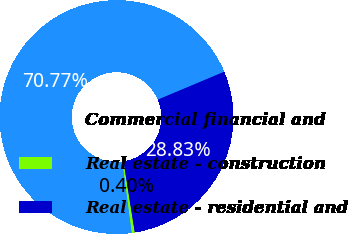Convert chart to OTSL. <chart><loc_0><loc_0><loc_500><loc_500><pie_chart><fcel>Commercial financial and<fcel>Real estate - construction<fcel>Real estate - residential and<nl><fcel>70.77%<fcel>0.4%<fcel>28.83%<nl></chart> 